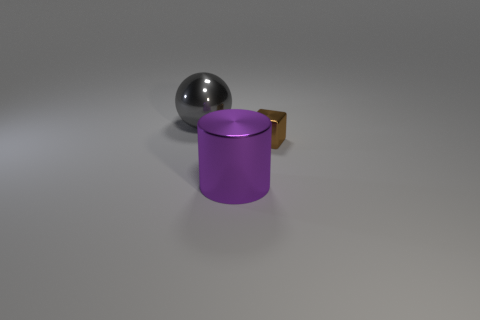Add 2 brown metal balls. How many objects exist? 5 Subtract all spheres. How many objects are left? 2 Subtract all big objects. Subtract all purple metallic cylinders. How many objects are left? 0 Add 1 tiny brown blocks. How many tiny brown blocks are left? 2 Add 3 large metallic cylinders. How many large metallic cylinders exist? 4 Subtract 0 yellow cylinders. How many objects are left? 3 